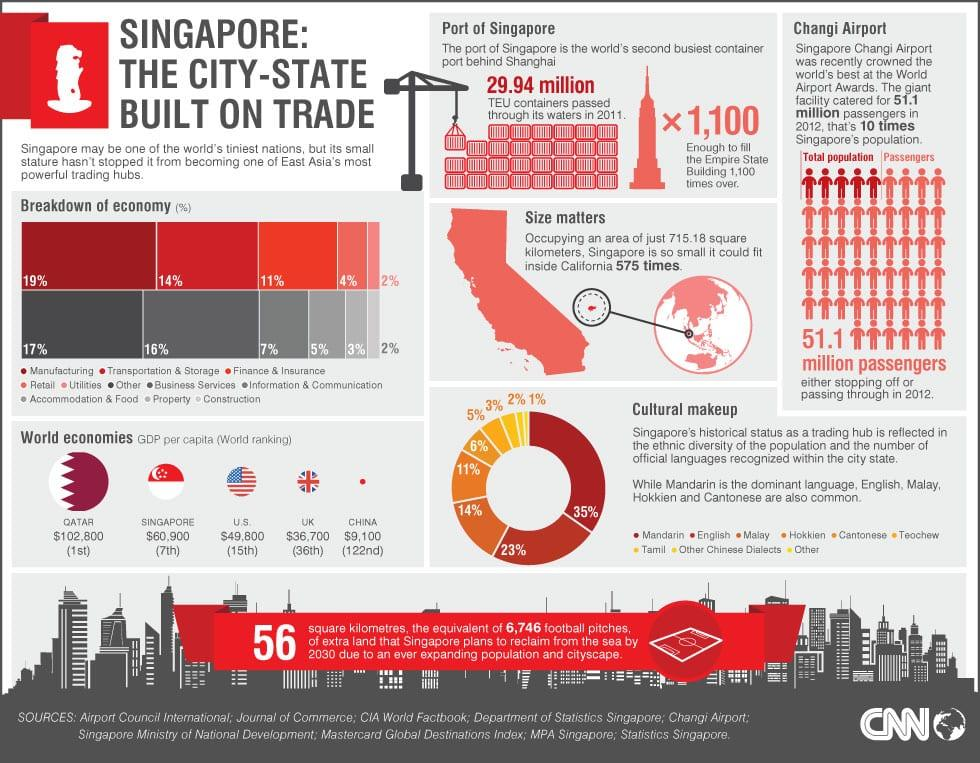Mention a couple of crucial points in this snapshot. Singapore is ranked the 7th largest economy in the world. According to available data, manufacturing, transportation and storage combined represent approximately 33% of the Gross Domestic Product (GDP). According to recent data, approximately 5% of the GDP is contributed by the property and construction sectors. Mandarin has the highest share in the languages of Singapore. The United Kingdom ranks 36th in the global economy. 